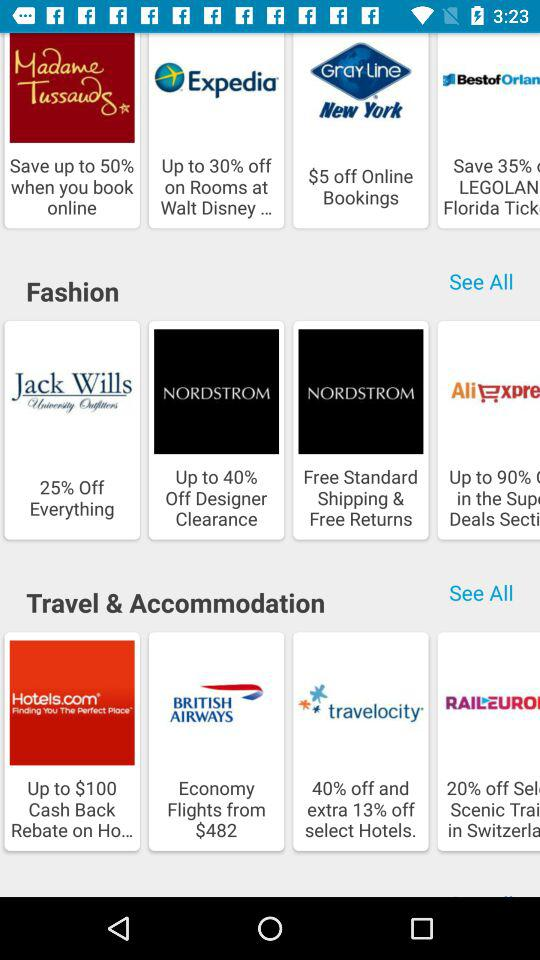How many percent off is the best deal in the Travel & Accommodation category?
Answer the question using a single word or phrase. 40% 